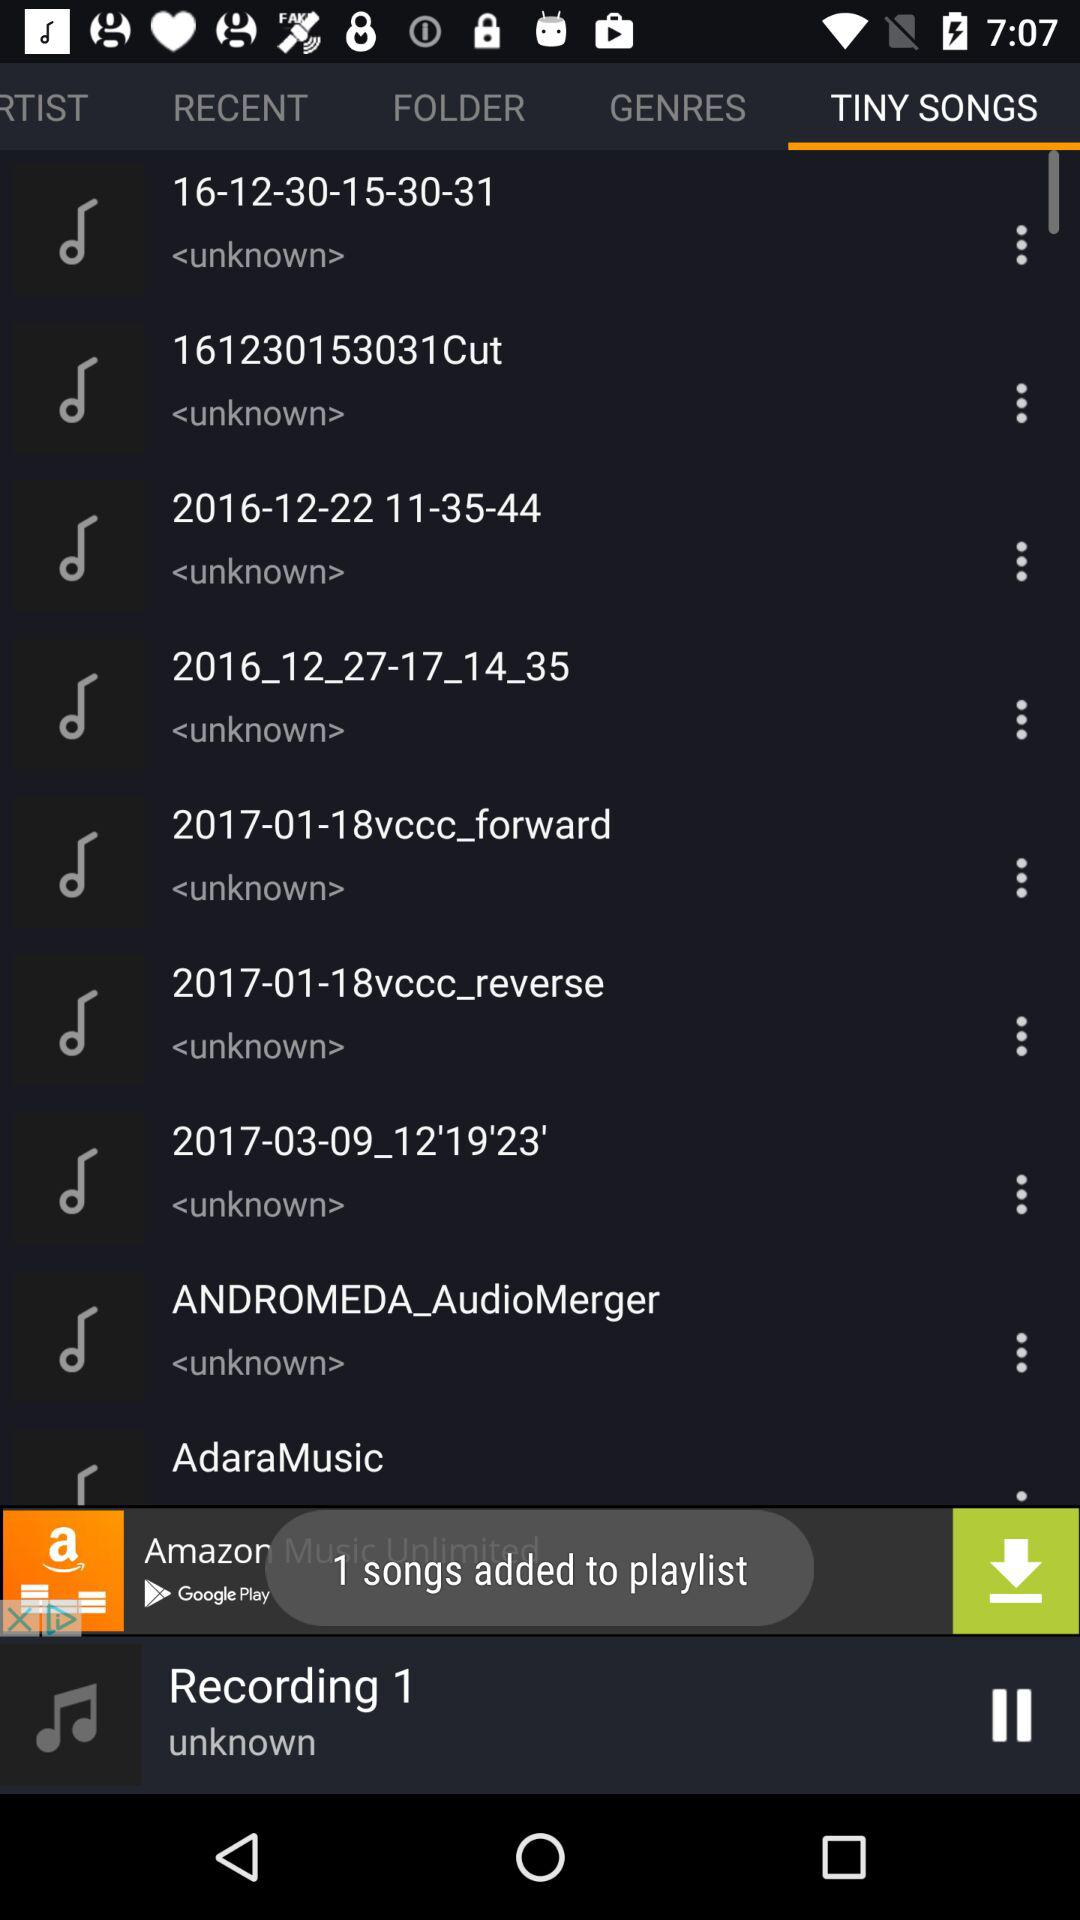Which tab is currently selected? The currently selected tab is "TINY SONGS". 